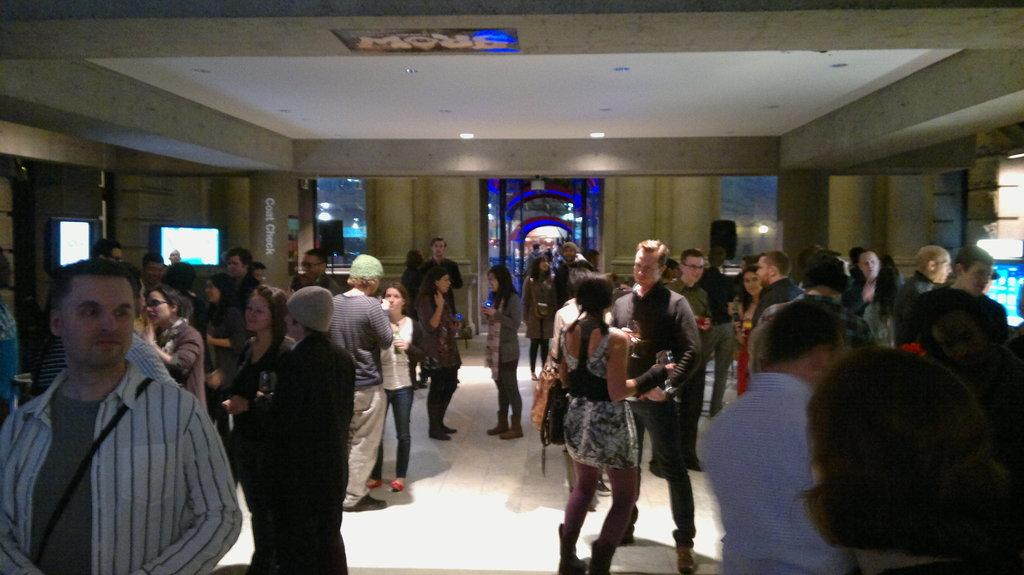What is happening in the image? There are people standing in a hall. What can be observed about the structure of the hall? The hall has walls. Are there any objects present in the hall? Yes, there are glasses in the hall. What is visible above the people in the image? The ceiling is visible in the hall. What feature of the hall provides illumination? There are lights in the hall. What flavor of quince is being served in the lunchroom in the image? There is no mention of quince or a lunchroom in the image; it simply shows people standing in a hall. 